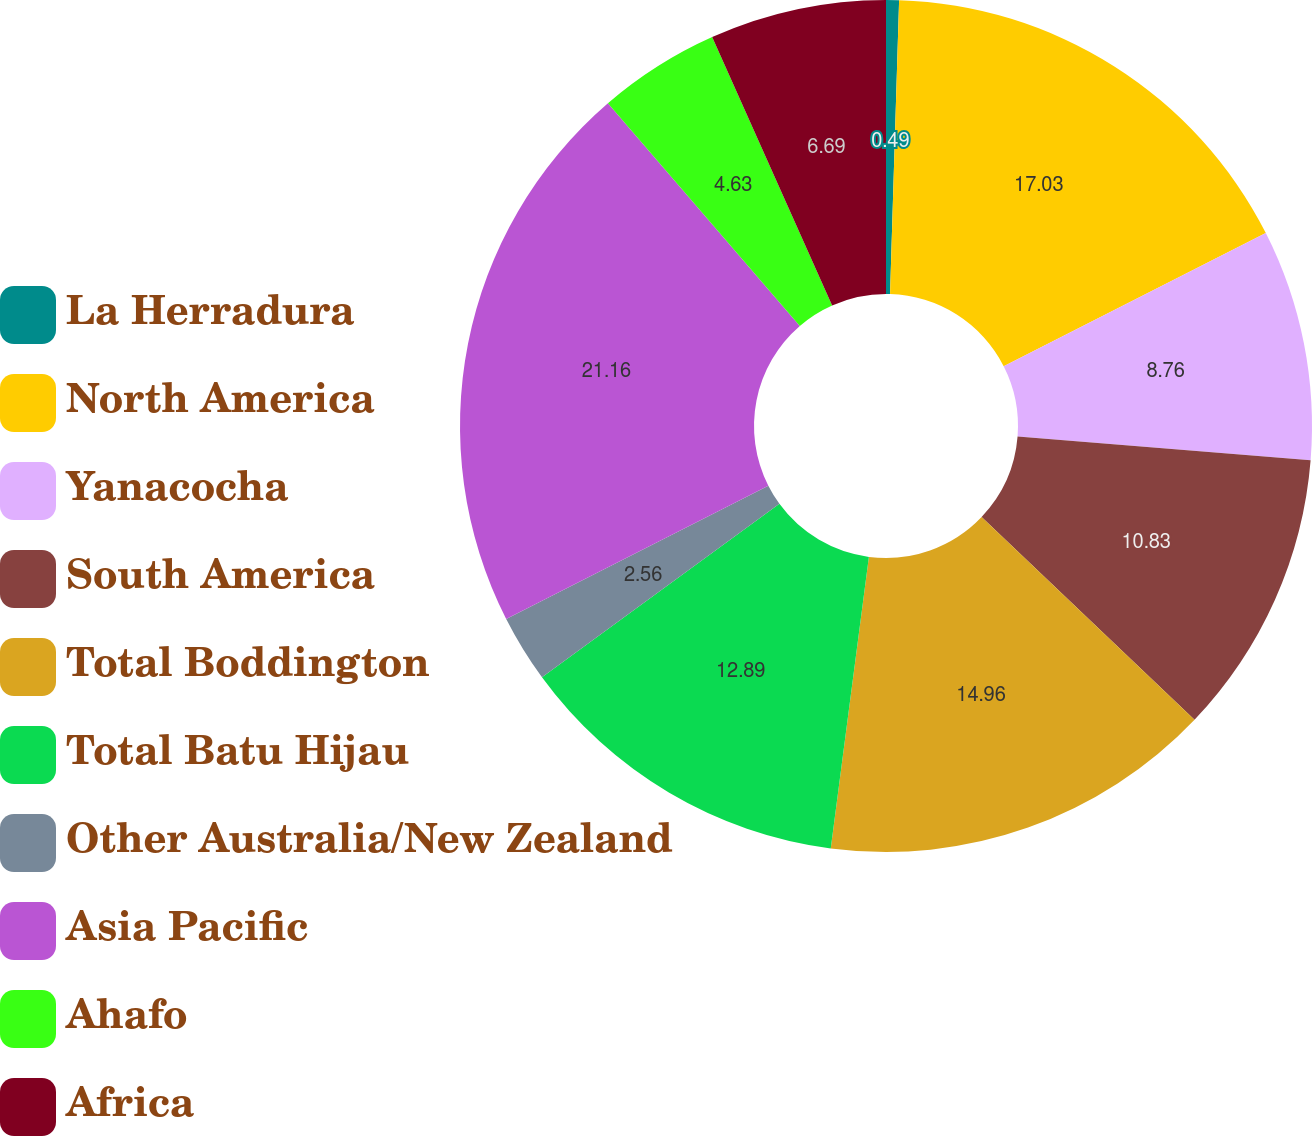Convert chart. <chart><loc_0><loc_0><loc_500><loc_500><pie_chart><fcel>La Herradura<fcel>North America<fcel>Yanacocha<fcel>South America<fcel>Total Boddington<fcel>Total Batu Hijau<fcel>Other Australia/New Zealand<fcel>Asia Pacific<fcel>Ahafo<fcel>Africa<nl><fcel>0.49%<fcel>17.03%<fcel>8.76%<fcel>10.83%<fcel>14.96%<fcel>12.89%<fcel>2.56%<fcel>21.16%<fcel>4.63%<fcel>6.69%<nl></chart> 